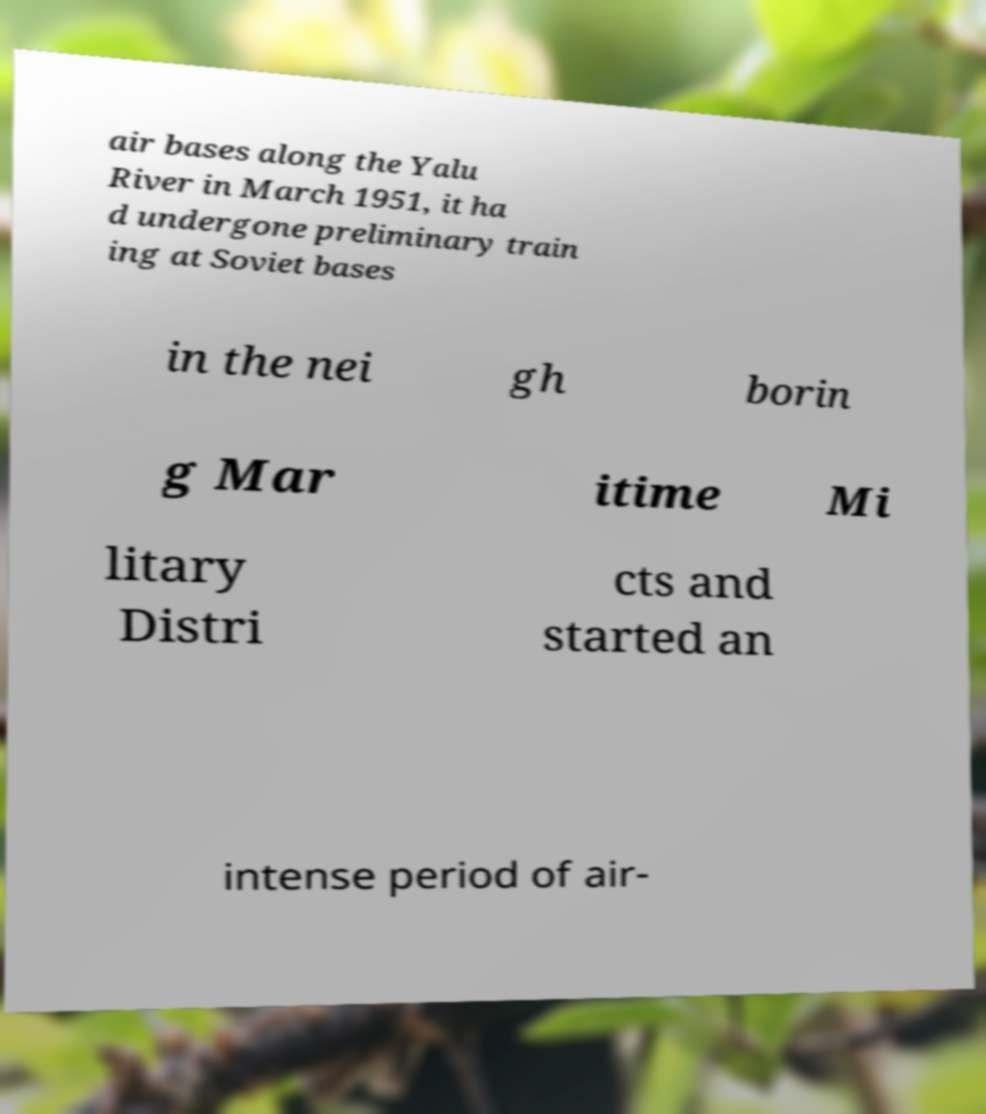I need the written content from this picture converted into text. Can you do that? air bases along the Yalu River in March 1951, it ha d undergone preliminary train ing at Soviet bases in the nei gh borin g Mar itime Mi litary Distri cts and started an intense period of air- 